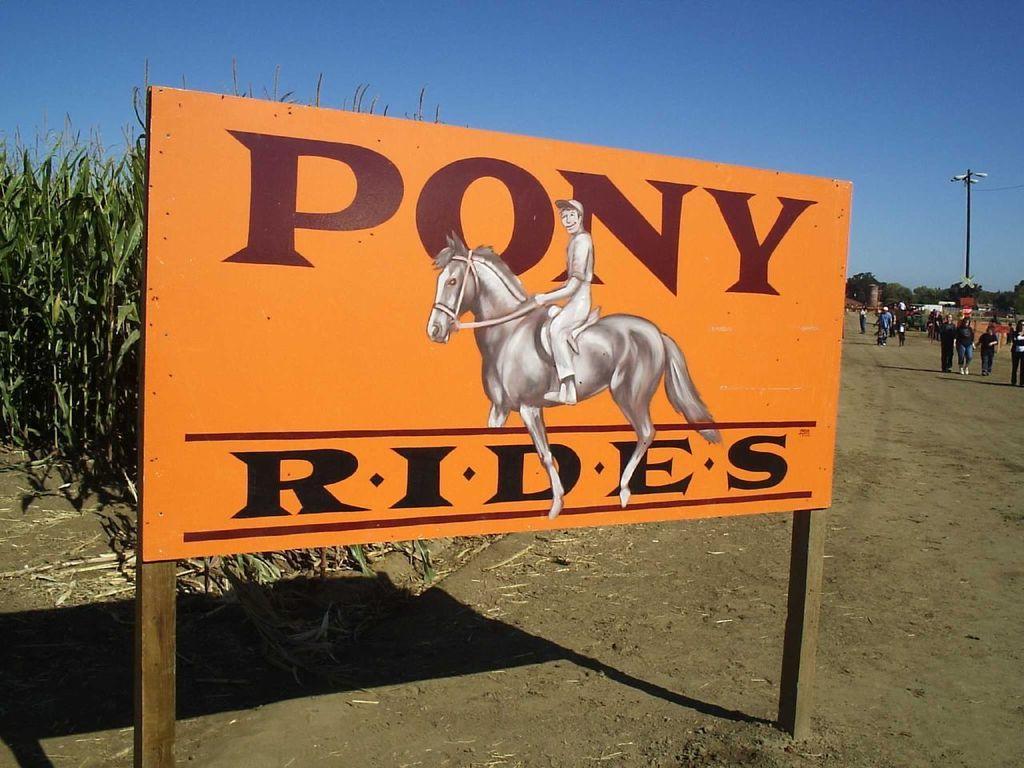In one or two sentences, can you explain what this image depicts? In the center of the image there is a board with some text and a depictions of a person and horse on it. In the background of the image there are crops. To the right side of the image there are people walking. There is light pole. At the top of the image there is sky. At the bottom of the image there is sand. 